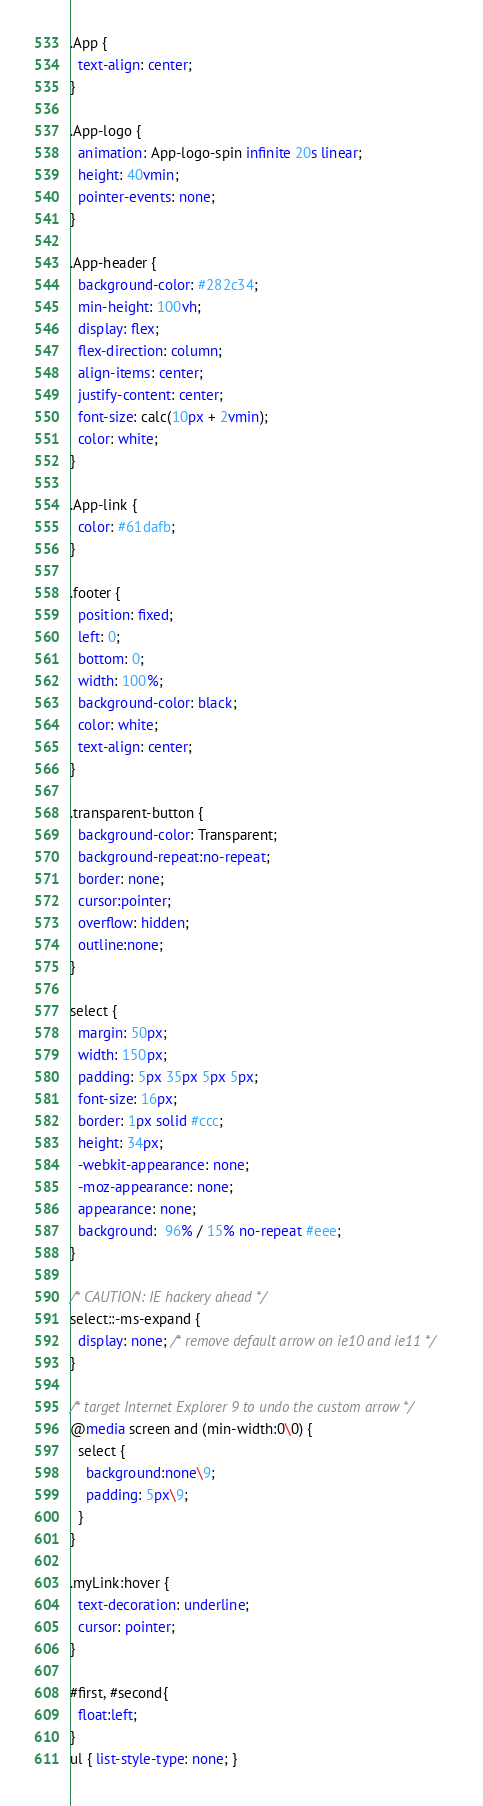Convert code to text. <code><loc_0><loc_0><loc_500><loc_500><_CSS_>.App {
  text-align: center;
}

.App-logo {
  animation: App-logo-spin infinite 20s linear;
  height: 40vmin;
  pointer-events: none;
}

.App-header {
  background-color: #282c34;
  min-height: 100vh;
  display: flex;
  flex-direction: column;
  align-items: center;
  justify-content: center;
  font-size: calc(10px + 2vmin);
  color: white;
}

.App-link {
  color: #61dafb;
}

.footer {
  position: fixed;
  left: 0;
  bottom: 0;
  width: 100%;
  background-color: black;
  color: white;
  text-align: center;
}

.transparent-button {
  background-color: Transparent;
  background-repeat:no-repeat;
  border: none;
  cursor:pointer;
  overflow: hidden;
  outline:none;
}

select {
  margin: 50px;
  width: 150px;
  padding: 5px 35px 5px 5px;
  font-size: 16px;
  border: 1px solid #ccc;
  height: 34px;
  -webkit-appearance: none;
  -moz-appearance: none;
  appearance: none;
  background:  96% / 15% no-repeat #eee;
}

/* CAUTION: IE hackery ahead */
select::-ms-expand {
  display: none; /* remove default arrow on ie10 and ie11 */
}

/* target Internet Explorer 9 to undo the custom arrow */
@media screen and (min-width:0\0) {
  select {
    background:none\9;
    padding: 5px\9;
  }
}

.myLink:hover {
  text-decoration: underline;
  cursor: pointer;
}

#first, #second{
  float:left;
}
ul { list-style-type: none; }
</code> 